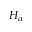Convert formula to latex. <formula><loc_0><loc_0><loc_500><loc_500>H _ { \alpha }</formula> 